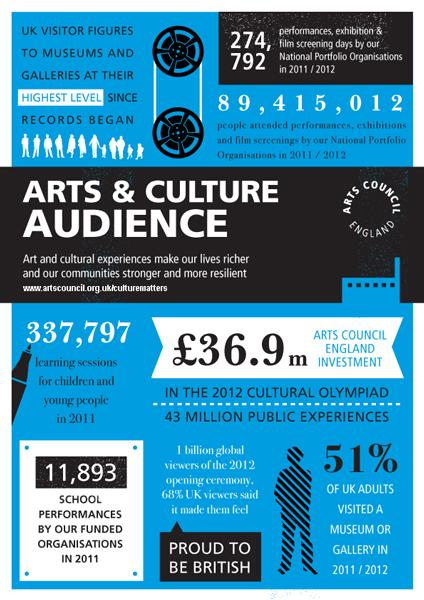Specify some key components in this picture. In 2011/2012, 49% of UK adults did not visit a museum or gallery. In 2011, a total of 11,893 school performances were organised by the funded organisations in the United Kingdom. The Arts Council England invested £36.9 million in the 2012 Cultural Olympiad. In 2011, 337,797 learning sessions were conducted for children and young people in the United Kingdom. In 2011/2012, a total of 274,792 performances, exhibition, and film screening days were organized by the National Portfolio Organizations in the United Kingdom. 